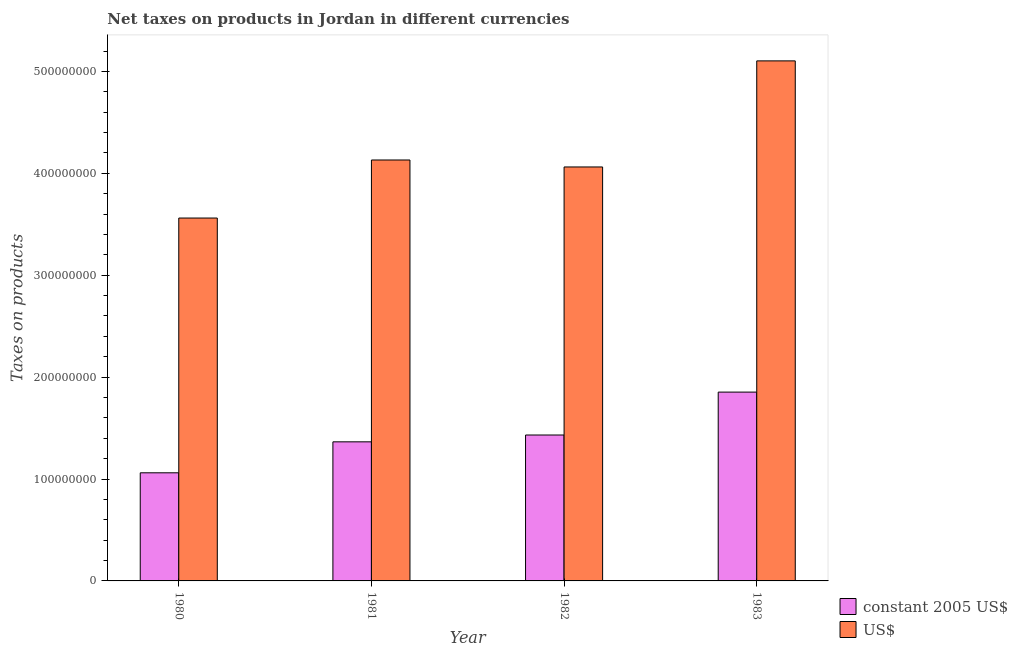How many different coloured bars are there?
Your answer should be very brief. 2. How many bars are there on the 3rd tick from the right?
Ensure brevity in your answer.  2. What is the label of the 1st group of bars from the left?
Your answer should be very brief. 1980. What is the net taxes in constant 2005 us$ in 1983?
Provide a short and direct response. 1.85e+08. Across all years, what is the maximum net taxes in constant 2005 us$?
Ensure brevity in your answer.  1.85e+08. Across all years, what is the minimum net taxes in constant 2005 us$?
Keep it short and to the point. 1.06e+08. In which year was the net taxes in constant 2005 us$ minimum?
Your answer should be very brief. 1980. What is the total net taxes in us$ in the graph?
Keep it short and to the point. 1.69e+09. What is the difference between the net taxes in constant 2005 us$ in 1981 and that in 1982?
Your response must be concise. -6.70e+06. What is the difference between the net taxes in constant 2005 us$ in 1982 and the net taxes in us$ in 1983?
Offer a terse response. -4.21e+07. What is the average net taxes in constant 2005 us$ per year?
Make the answer very short. 1.43e+08. In the year 1981, what is the difference between the net taxes in us$ and net taxes in constant 2005 us$?
Offer a very short reply. 0. In how many years, is the net taxes in us$ greater than 380000000 units?
Offer a very short reply. 3. What is the ratio of the net taxes in constant 2005 us$ in 1980 to that in 1983?
Offer a terse response. 0.57. Is the difference between the net taxes in us$ in 1980 and 1983 greater than the difference between the net taxes in constant 2005 us$ in 1980 and 1983?
Your answer should be compact. No. What is the difference between the highest and the second highest net taxes in constant 2005 us$?
Keep it short and to the point. 4.21e+07. What is the difference between the highest and the lowest net taxes in us$?
Make the answer very short. 1.54e+08. What does the 1st bar from the left in 1982 represents?
Provide a short and direct response. Constant 2005 us$. What does the 2nd bar from the right in 1982 represents?
Provide a succinct answer. Constant 2005 us$. How many bars are there?
Offer a terse response. 8. Are all the bars in the graph horizontal?
Offer a terse response. No. What is the difference between two consecutive major ticks on the Y-axis?
Give a very brief answer. 1.00e+08. Does the graph contain any zero values?
Make the answer very short. No. Does the graph contain grids?
Offer a terse response. No. How are the legend labels stacked?
Offer a terse response. Vertical. What is the title of the graph?
Your answer should be compact. Net taxes on products in Jordan in different currencies. What is the label or title of the Y-axis?
Your answer should be very brief. Taxes on products. What is the Taxes on products in constant 2005 US$ in 1980?
Your answer should be very brief. 1.06e+08. What is the Taxes on products in US$ in 1980?
Give a very brief answer. 3.56e+08. What is the Taxes on products of constant 2005 US$ in 1981?
Ensure brevity in your answer.  1.36e+08. What is the Taxes on products in US$ in 1981?
Your response must be concise. 4.13e+08. What is the Taxes on products of constant 2005 US$ in 1982?
Make the answer very short. 1.43e+08. What is the Taxes on products in US$ in 1982?
Provide a short and direct response. 4.06e+08. What is the Taxes on products of constant 2005 US$ in 1983?
Your response must be concise. 1.85e+08. What is the Taxes on products of US$ in 1983?
Ensure brevity in your answer.  5.10e+08. Across all years, what is the maximum Taxes on products in constant 2005 US$?
Your answer should be compact. 1.85e+08. Across all years, what is the maximum Taxes on products in US$?
Offer a very short reply. 5.10e+08. Across all years, what is the minimum Taxes on products of constant 2005 US$?
Keep it short and to the point. 1.06e+08. Across all years, what is the minimum Taxes on products of US$?
Your response must be concise. 3.56e+08. What is the total Taxes on products in constant 2005 US$ in the graph?
Provide a succinct answer. 5.71e+08. What is the total Taxes on products of US$ in the graph?
Your answer should be compact. 1.69e+09. What is the difference between the Taxes on products of constant 2005 US$ in 1980 and that in 1981?
Provide a short and direct response. -3.04e+07. What is the difference between the Taxes on products in US$ in 1980 and that in 1981?
Your response must be concise. -5.70e+07. What is the difference between the Taxes on products of constant 2005 US$ in 1980 and that in 1982?
Your response must be concise. -3.71e+07. What is the difference between the Taxes on products of US$ in 1980 and that in 1982?
Keep it short and to the point. -5.01e+07. What is the difference between the Taxes on products of constant 2005 US$ in 1980 and that in 1983?
Offer a very short reply. -7.92e+07. What is the difference between the Taxes on products of US$ in 1980 and that in 1983?
Your response must be concise. -1.54e+08. What is the difference between the Taxes on products of constant 2005 US$ in 1981 and that in 1982?
Give a very brief answer. -6.70e+06. What is the difference between the Taxes on products of US$ in 1981 and that in 1982?
Your answer should be compact. 6.84e+06. What is the difference between the Taxes on products of constant 2005 US$ in 1981 and that in 1983?
Offer a terse response. -4.88e+07. What is the difference between the Taxes on products in US$ in 1981 and that in 1983?
Offer a very short reply. -9.73e+07. What is the difference between the Taxes on products of constant 2005 US$ in 1982 and that in 1983?
Make the answer very short. -4.21e+07. What is the difference between the Taxes on products in US$ in 1982 and that in 1983?
Your answer should be very brief. -1.04e+08. What is the difference between the Taxes on products in constant 2005 US$ in 1980 and the Taxes on products in US$ in 1981?
Ensure brevity in your answer.  -3.07e+08. What is the difference between the Taxes on products of constant 2005 US$ in 1980 and the Taxes on products of US$ in 1982?
Make the answer very short. -3.00e+08. What is the difference between the Taxes on products in constant 2005 US$ in 1980 and the Taxes on products in US$ in 1983?
Your answer should be very brief. -4.04e+08. What is the difference between the Taxes on products in constant 2005 US$ in 1981 and the Taxes on products in US$ in 1982?
Make the answer very short. -2.70e+08. What is the difference between the Taxes on products in constant 2005 US$ in 1981 and the Taxes on products in US$ in 1983?
Offer a terse response. -3.74e+08. What is the difference between the Taxes on products in constant 2005 US$ in 1982 and the Taxes on products in US$ in 1983?
Ensure brevity in your answer.  -3.67e+08. What is the average Taxes on products of constant 2005 US$ per year?
Keep it short and to the point. 1.43e+08. What is the average Taxes on products in US$ per year?
Make the answer very short. 4.21e+08. In the year 1980, what is the difference between the Taxes on products in constant 2005 US$ and Taxes on products in US$?
Make the answer very short. -2.50e+08. In the year 1981, what is the difference between the Taxes on products of constant 2005 US$ and Taxes on products of US$?
Give a very brief answer. -2.77e+08. In the year 1982, what is the difference between the Taxes on products of constant 2005 US$ and Taxes on products of US$?
Offer a very short reply. -2.63e+08. In the year 1983, what is the difference between the Taxes on products of constant 2005 US$ and Taxes on products of US$?
Offer a very short reply. -3.25e+08. What is the ratio of the Taxes on products of constant 2005 US$ in 1980 to that in 1981?
Keep it short and to the point. 0.78. What is the ratio of the Taxes on products in US$ in 1980 to that in 1981?
Your answer should be very brief. 0.86. What is the ratio of the Taxes on products of constant 2005 US$ in 1980 to that in 1982?
Make the answer very short. 0.74. What is the ratio of the Taxes on products of US$ in 1980 to that in 1982?
Ensure brevity in your answer.  0.88. What is the ratio of the Taxes on products of constant 2005 US$ in 1980 to that in 1983?
Keep it short and to the point. 0.57. What is the ratio of the Taxes on products in US$ in 1980 to that in 1983?
Your answer should be compact. 0.7. What is the ratio of the Taxes on products of constant 2005 US$ in 1981 to that in 1982?
Provide a short and direct response. 0.95. What is the ratio of the Taxes on products in US$ in 1981 to that in 1982?
Offer a very short reply. 1.02. What is the ratio of the Taxes on products in constant 2005 US$ in 1981 to that in 1983?
Your response must be concise. 0.74. What is the ratio of the Taxes on products in US$ in 1981 to that in 1983?
Make the answer very short. 0.81. What is the ratio of the Taxes on products of constant 2005 US$ in 1982 to that in 1983?
Offer a terse response. 0.77. What is the ratio of the Taxes on products of US$ in 1982 to that in 1983?
Provide a succinct answer. 0.8. What is the difference between the highest and the second highest Taxes on products in constant 2005 US$?
Provide a succinct answer. 4.21e+07. What is the difference between the highest and the second highest Taxes on products in US$?
Ensure brevity in your answer.  9.73e+07. What is the difference between the highest and the lowest Taxes on products in constant 2005 US$?
Offer a very short reply. 7.92e+07. What is the difference between the highest and the lowest Taxes on products of US$?
Your response must be concise. 1.54e+08. 